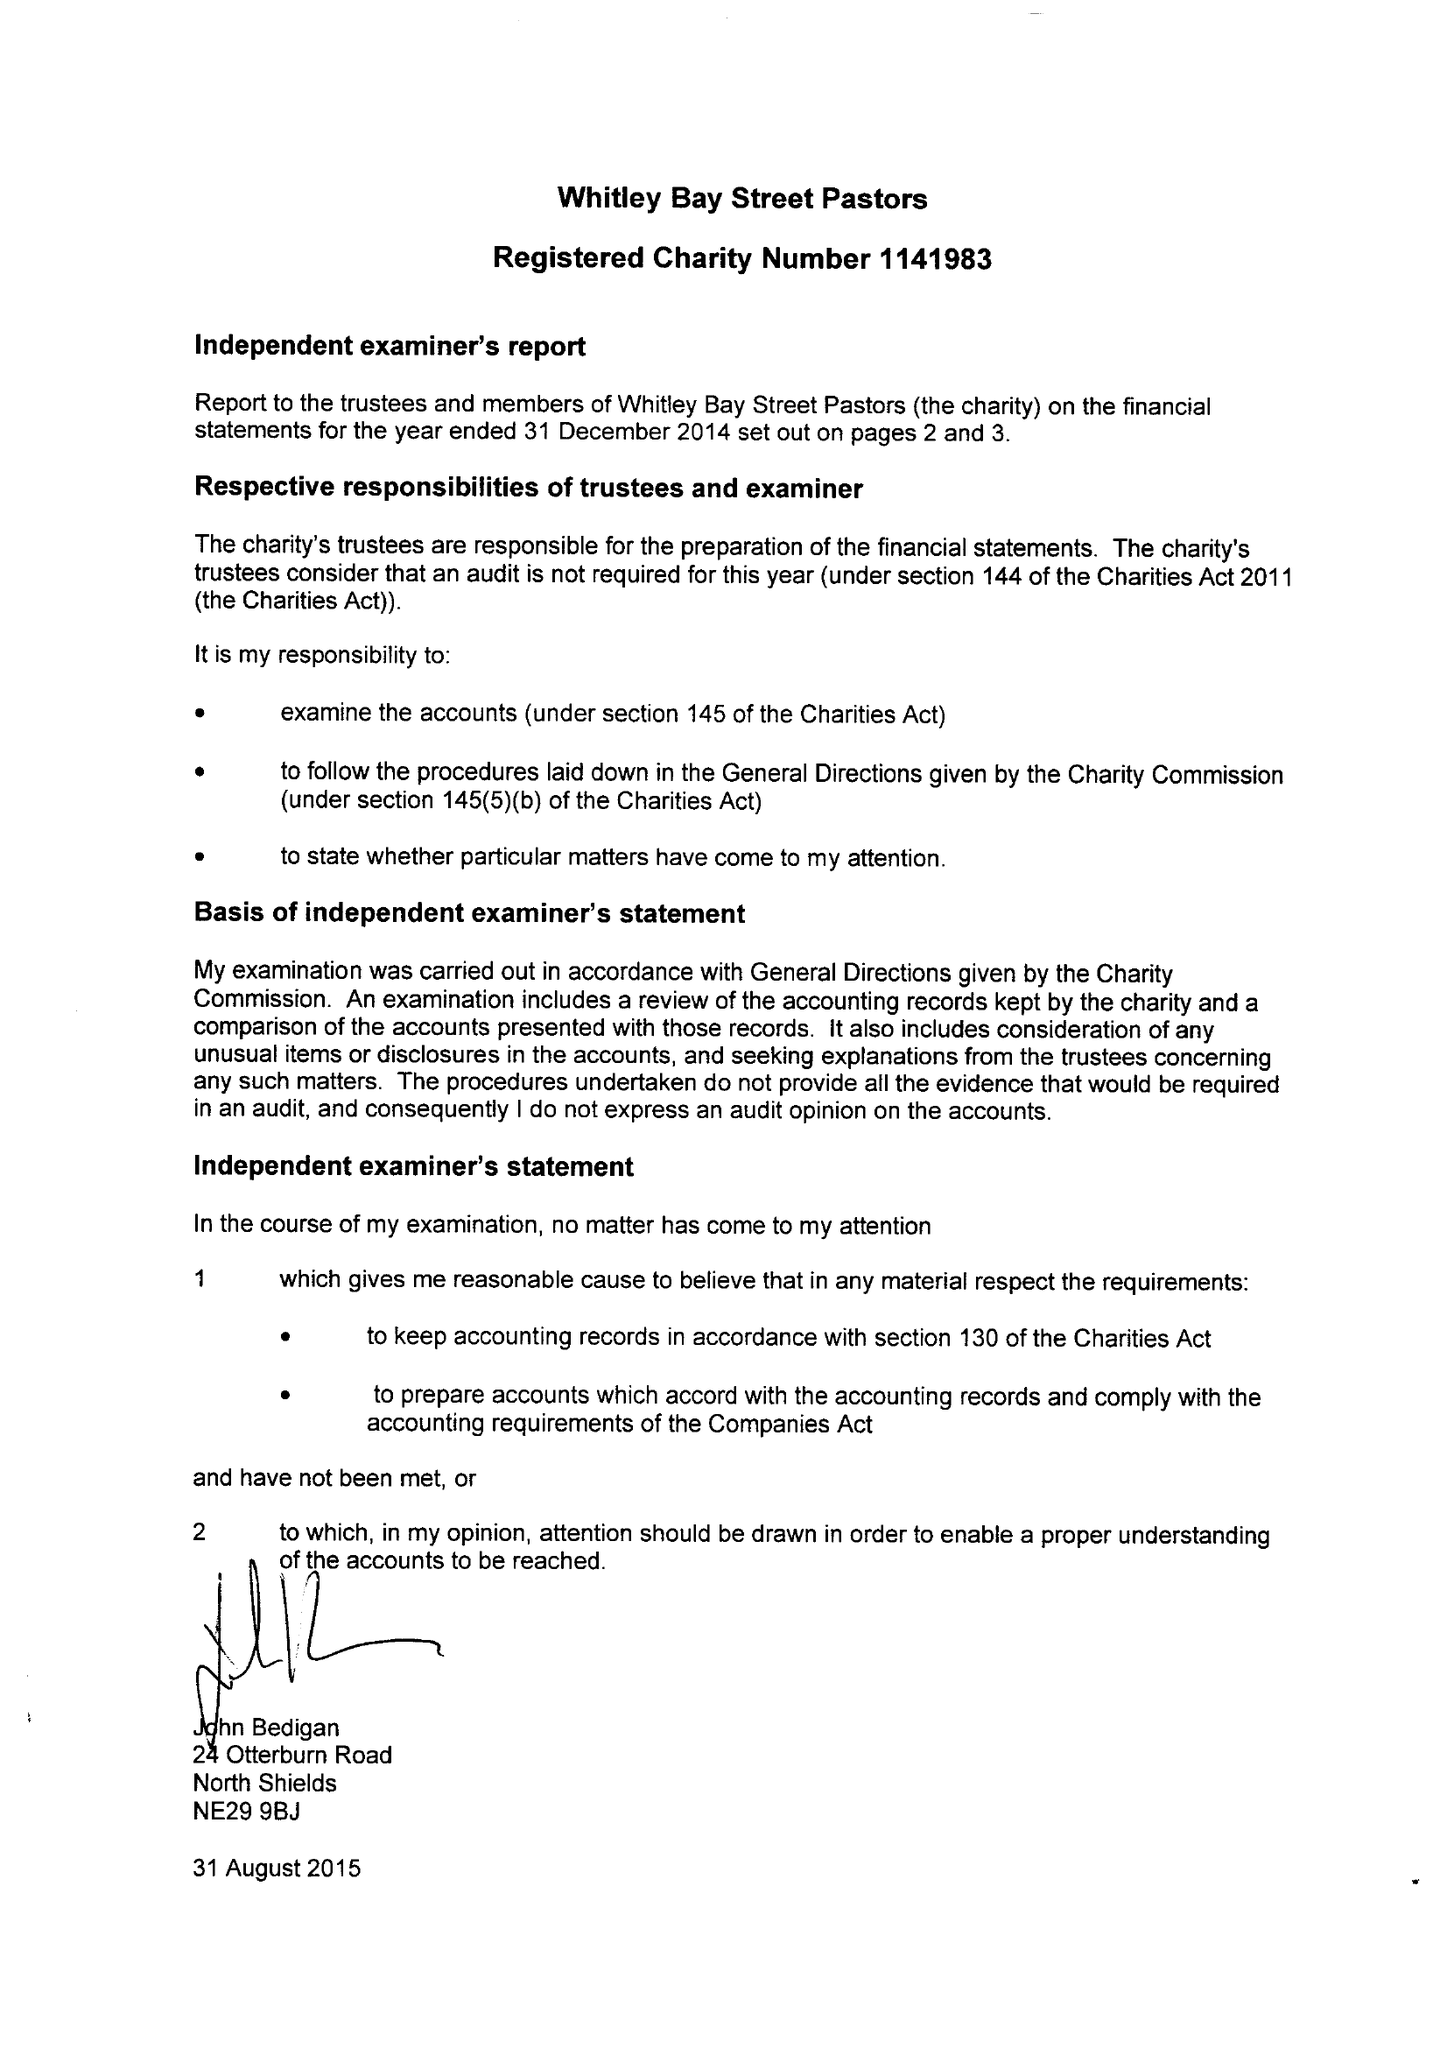What is the value for the income_annually_in_british_pounds?
Answer the question using a single word or phrase. 29382.00 